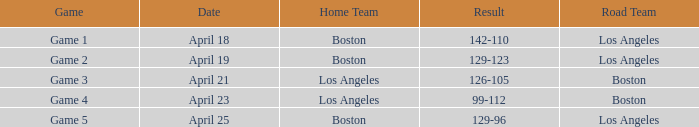WHAT IS THE RESULT WITH THE BOSTON ROAD TEAM, ON APRIL 23? 99-112. 